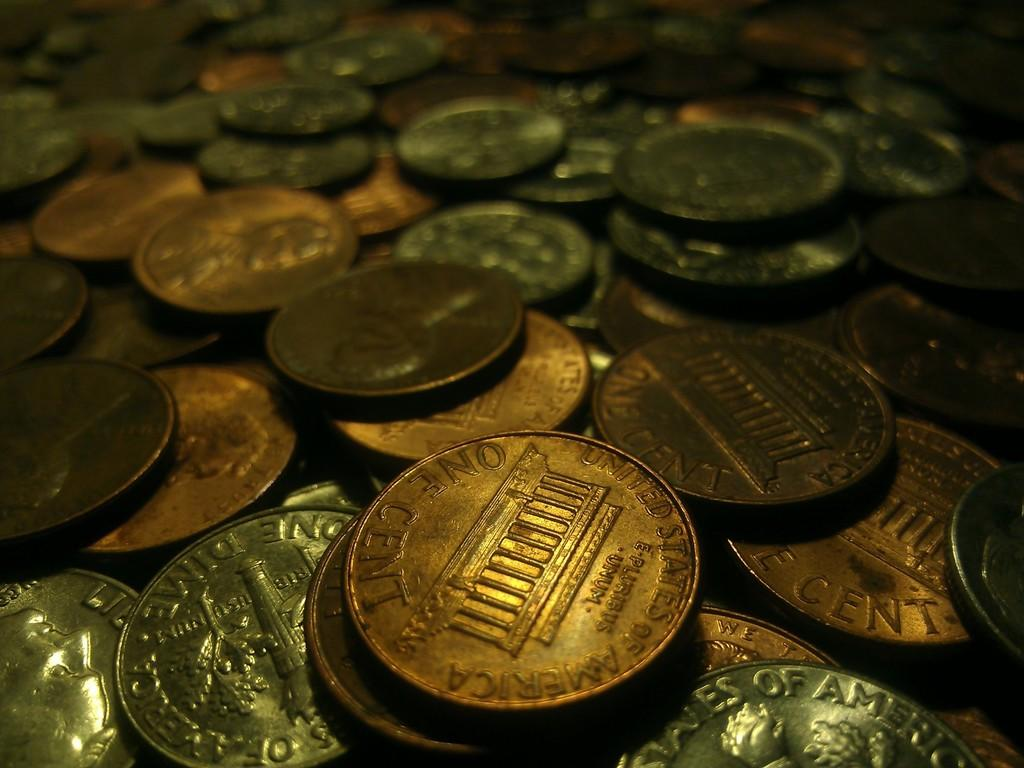<image>
Write a terse but informative summary of the picture. A coin has United States of America stamped on it. 